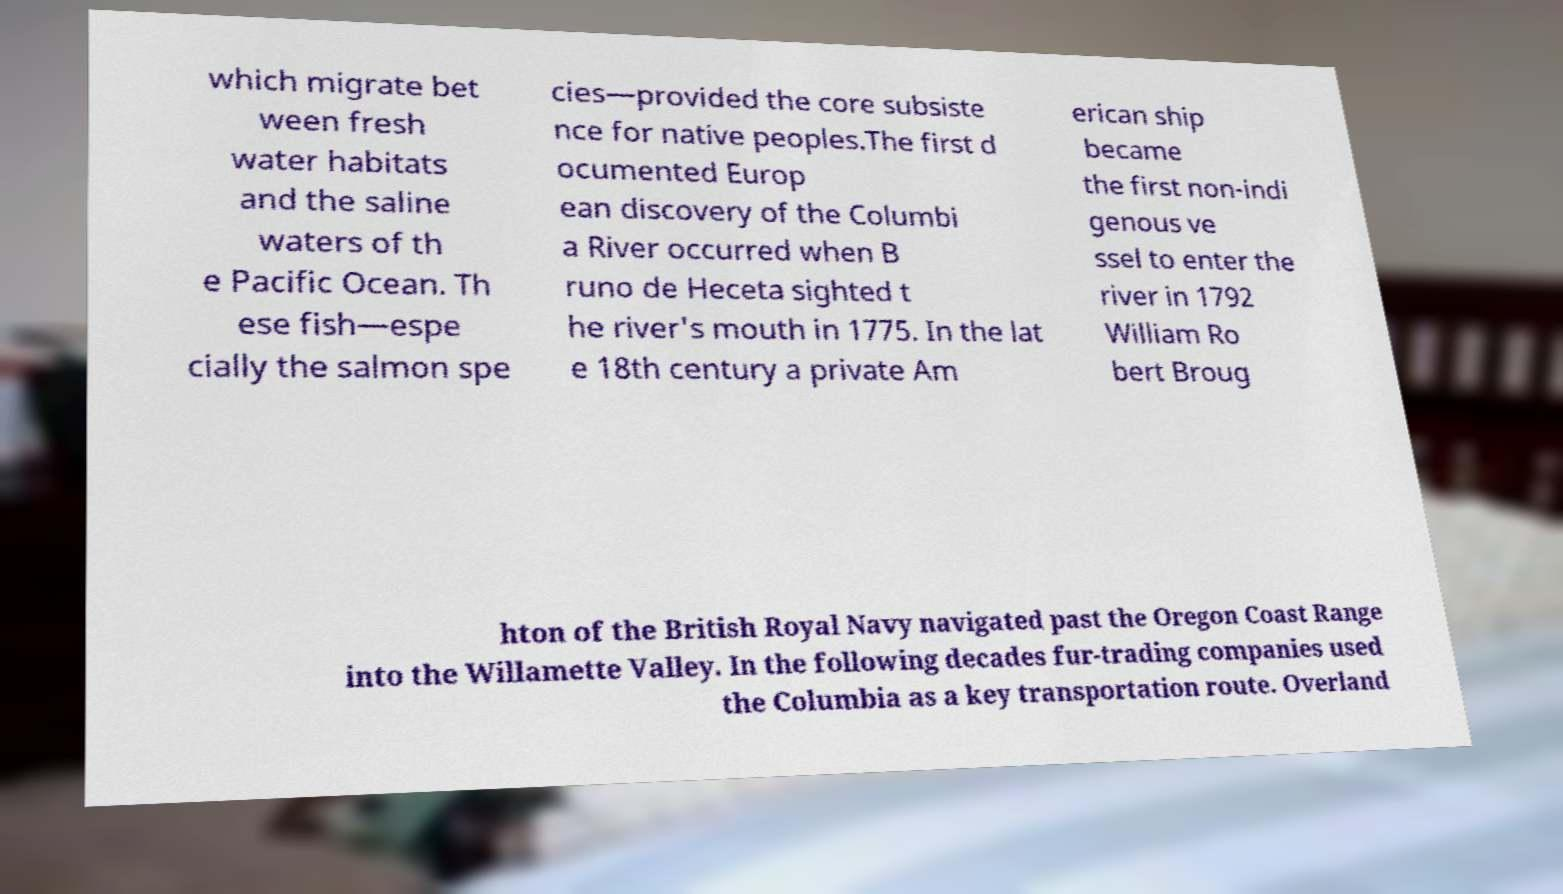Can you read and provide the text displayed in the image?This photo seems to have some interesting text. Can you extract and type it out for me? which migrate bet ween fresh water habitats and the saline waters of th e Pacific Ocean. Th ese fish—espe cially the salmon spe cies—provided the core subsiste nce for native peoples.The first d ocumented Europ ean discovery of the Columbi a River occurred when B runo de Heceta sighted t he river's mouth in 1775. In the lat e 18th century a private Am erican ship became the first non-indi genous ve ssel to enter the river in 1792 William Ro bert Broug hton of the British Royal Navy navigated past the Oregon Coast Range into the Willamette Valley. In the following decades fur-trading companies used the Columbia as a key transportation route. Overland 